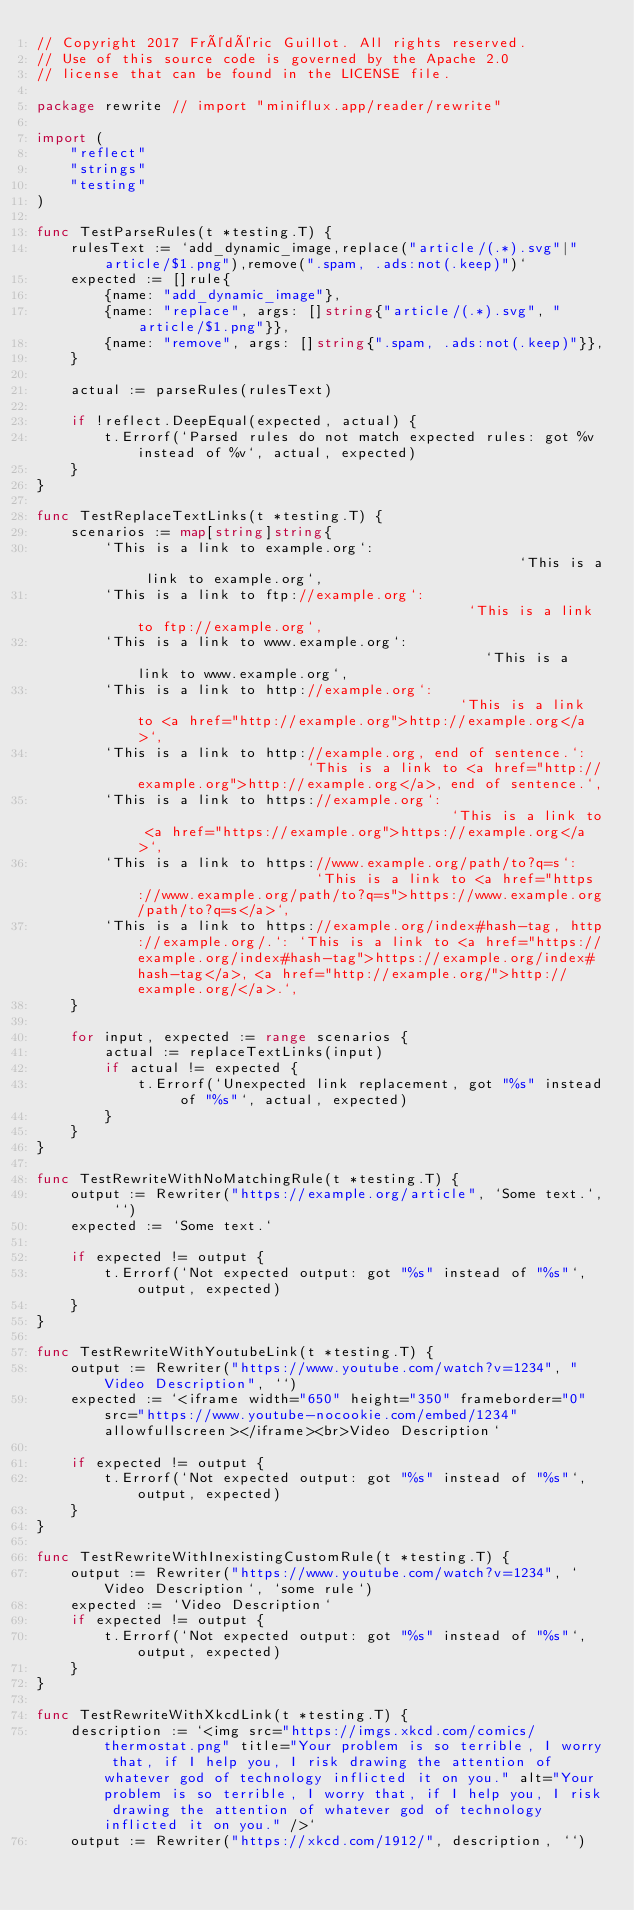Convert code to text. <code><loc_0><loc_0><loc_500><loc_500><_Go_>// Copyright 2017 Frédéric Guillot. All rights reserved.
// Use of this source code is governed by the Apache 2.0
// license that can be found in the LICENSE file.

package rewrite // import "miniflux.app/reader/rewrite"

import (
	"reflect"
	"strings"
	"testing"
)

func TestParseRules(t *testing.T) {
	rulesText := `add_dynamic_image,replace("article/(.*).svg"|"article/$1.png"),remove(".spam, .ads:not(.keep)")`
	expected := []rule{
		{name: "add_dynamic_image"},
		{name: "replace", args: []string{"article/(.*).svg", "article/$1.png"}},
		{name: "remove", args: []string{".spam, .ads:not(.keep)"}},
	}

	actual := parseRules(rulesText)

	if !reflect.DeepEqual(expected, actual) {
		t.Errorf(`Parsed rules do not match expected rules: got %v instead of %v`, actual, expected)
	}
}

func TestReplaceTextLinks(t *testing.T) {
	scenarios := map[string]string{
		`This is a link to example.org`:                                              `This is a link to example.org`,
		`This is a link to ftp://example.org`:                                        `This is a link to ftp://example.org`,
		`This is a link to www.example.org`:                                          `This is a link to www.example.org`,
		`This is a link to http://example.org`:                                       `This is a link to <a href="http://example.org">http://example.org</a>`,
		`This is a link to http://example.org, end of sentence.`:                     `This is a link to <a href="http://example.org">http://example.org</a>, end of sentence.`,
		`This is a link to https://example.org`:                                      `This is a link to <a href="https://example.org">https://example.org</a>`,
		`This is a link to https://www.example.org/path/to?q=s`:                      `This is a link to <a href="https://www.example.org/path/to?q=s">https://www.example.org/path/to?q=s</a>`,
		`This is a link to https://example.org/index#hash-tag, http://example.org/.`: `This is a link to <a href="https://example.org/index#hash-tag">https://example.org/index#hash-tag</a>, <a href="http://example.org/">http://example.org/</a>.`,
	}

	for input, expected := range scenarios {
		actual := replaceTextLinks(input)
		if actual != expected {
			t.Errorf(`Unexpected link replacement, got "%s" instead of "%s"`, actual, expected)
		}
	}
}

func TestRewriteWithNoMatchingRule(t *testing.T) {
	output := Rewriter("https://example.org/article", `Some text.`, ``)
	expected := `Some text.`

	if expected != output {
		t.Errorf(`Not expected output: got "%s" instead of "%s"`, output, expected)
	}
}

func TestRewriteWithYoutubeLink(t *testing.T) {
	output := Rewriter("https://www.youtube.com/watch?v=1234", "Video Description", ``)
	expected := `<iframe width="650" height="350" frameborder="0" src="https://www.youtube-nocookie.com/embed/1234" allowfullscreen></iframe><br>Video Description`

	if expected != output {
		t.Errorf(`Not expected output: got "%s" instead of "%s"`, output, expected)
	}
}

func TestRewriteWithInexistingCustomRule(t *testing.T) {
	output := Rewriter("https://www.youtube.com/watch?v=1234", `Video Description`, `some rule`)
	expected := `Video Description`
	if expected != output {
		t.Errorf(`Not expected output: got "%s" instead of "%s"`, output, expected)
	}
}

func TestRewriteWithXkcdLink(t *testing.T) {
	description := `<img src="https://imgs.xkcd.com/comics/thermostat.png" title="Your problem is so terrible, I worry that, if I help you, I risk drawing the attention of whatever god of technology inflicted it on you." alt="Your problem is so terrible, I worry that, if I help you, I risk drawing the attention of whatever god of technology inflicted it on you." />`
	output := Rewriter("https://xkcd.com/1912/", description, ``)</code> 